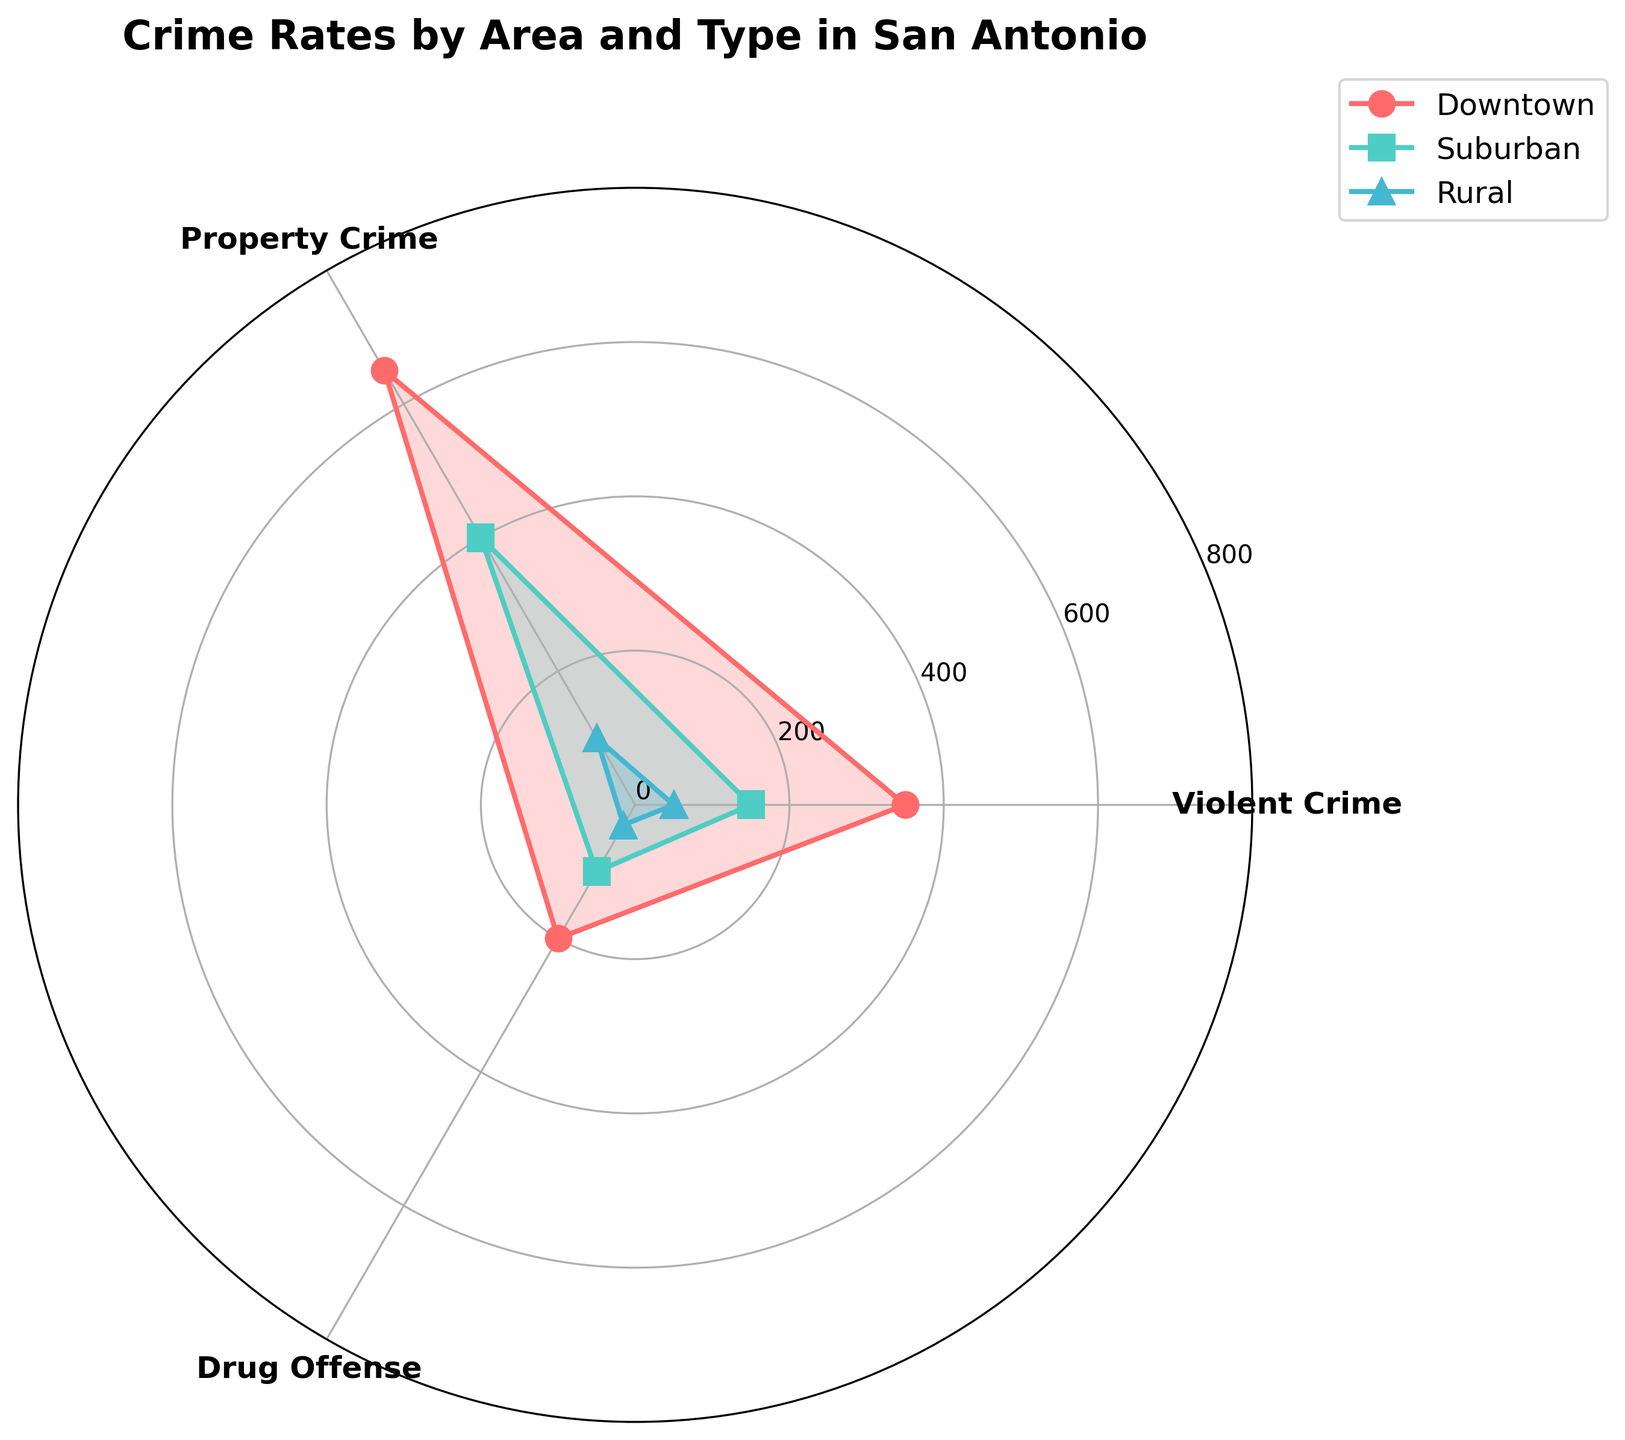What is the title of the chart? The title of the chart is written at the top. It states the topic of the visualization.
Answer: Crime Rates by Area and Type in San Antonio How many crime types are represented in the chart? By looking at the x-axis or the legend, we can see the different categories labeled.
Answer: 3 Which area has the highest total crime rate? Adding up the crime rates for each crime type for each area, Downtown has the highest total (350 + 650 + 200 = 1200), Suburban is next (150 + 400 + 100 = 650), and Rural is the lowest (50 + 100 + 30 = 180).
Answer: Downtown Which area has the lowest rate of violent crime? By observing the length of the bars or lines for the violent crime category, we see that Rural has the smallest value.
Answer: Rural Compare the property crime rates in Downtown and Suburban areas. Which one is higher, and by how much? Downtown's property crime rate is 650, while Suburban's is 400. So, Downtown is higher by 650 - 400 = 250.
Answer: Downtown, 250 What is the difference in drug offense rates between the Suburban and Rural areas? Looking at the values for the drug offense category, Suburban has 100 and Rural has 30. The difference is 100 - 30 = 70.
Answer: 70 Which area has the highest property crime rate? By comparing the sections for property crime, the highest value is observed for Downtown.
Answer: Downtown What is the average crime rate for Suburban across all crime types? Summing up the Suburban values (150 + 400 + 100 = 650) and dividing by the number of types (3), we get 650 / 3 ≈ 216.67.
Answer: 216.67 Is the drug offense rate higher in Downtown or Suburban? By comparing the drug offense rates, Downtown has 200 and Suburban has 100. Downtown is higher.
Answer: Downtown In which area are violent crimes least frequent relative to property crimes and drug offenses? By comparing the relative sizes of the violent crimes to property crimes and drug offenses across all areas, the Rural area shows the smallest proportion for violent crimes.
Answer: Rural 